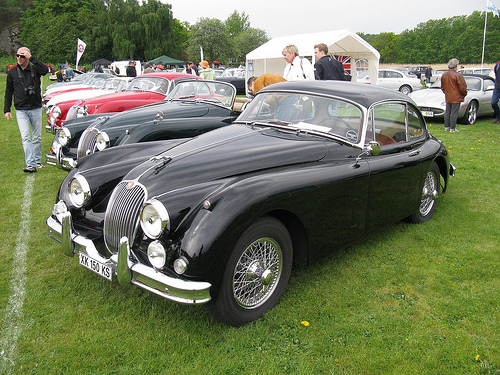<image>
Is the car in front of the man? No. The car is not in front of the man. The spatial positioning shows a different relationship between these objects. 